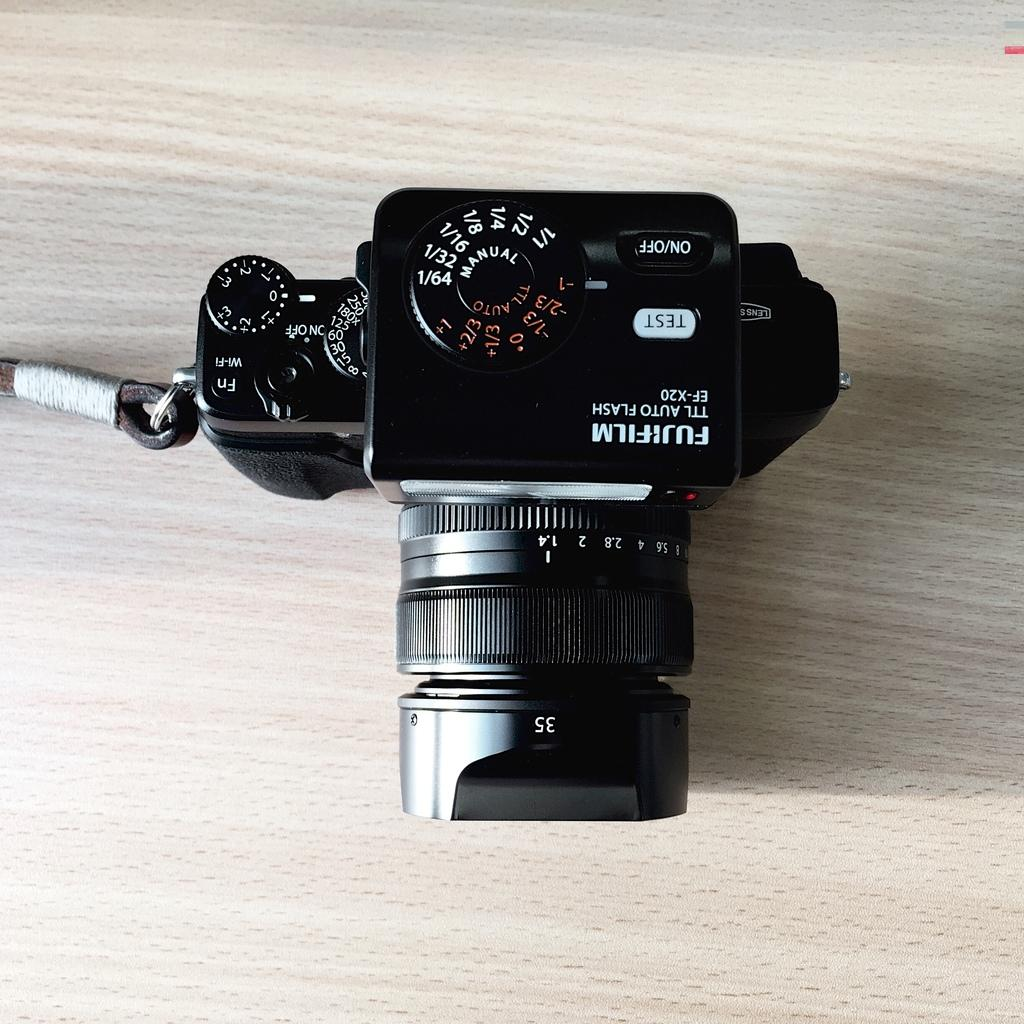What is the main object in the image? There is a camera in the image. Where is the camera placed? The camera is on a wooden surface. Where is the faucet located in the image? There is no faucet present in the image. What type of flowers can be seen growing near the camera in the image? There are no flowers present in the image. 